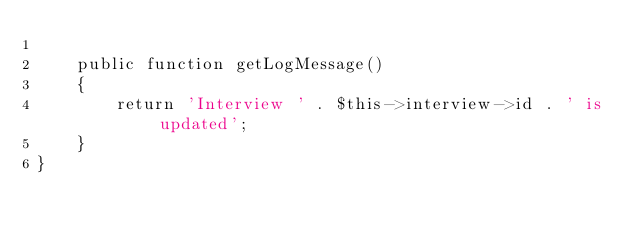Convert code to text. <code><loc_0><loc_0><loc_500><loc_500><_PHP_>
    public function getLogMessage()
    {
        return 'Interview ' . $this->interview->id . ' is updated';
    }
} </code> 